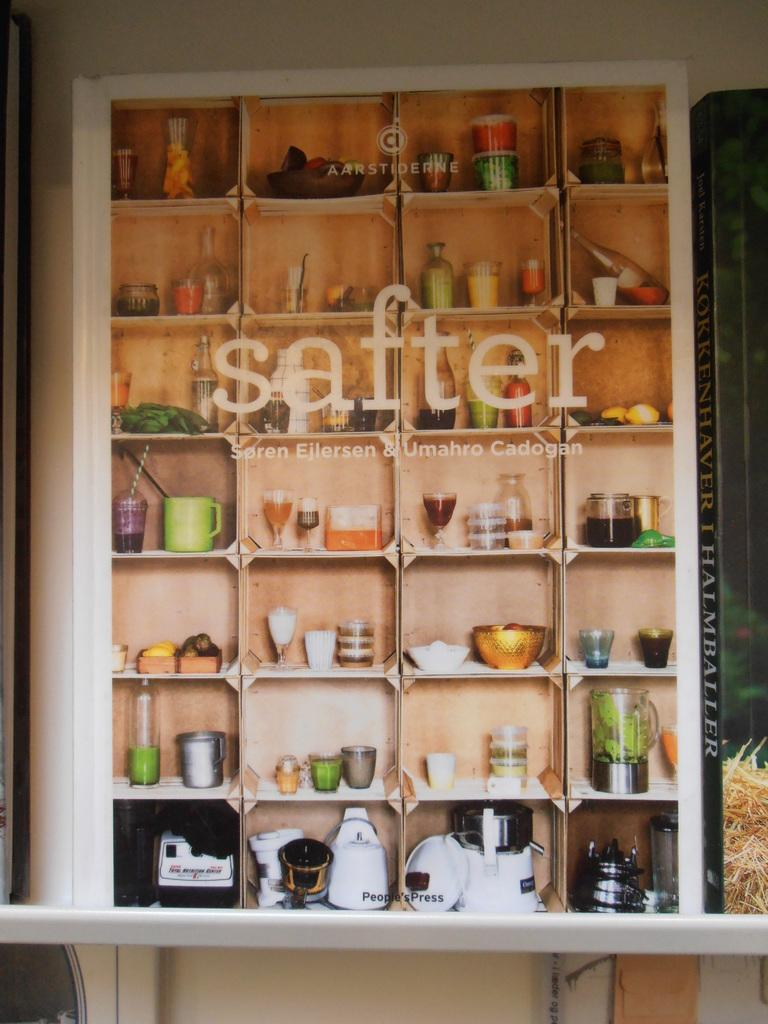<image>
Present a compact description of the photo's key features. Shelf that says the word "safter" in front of it. 